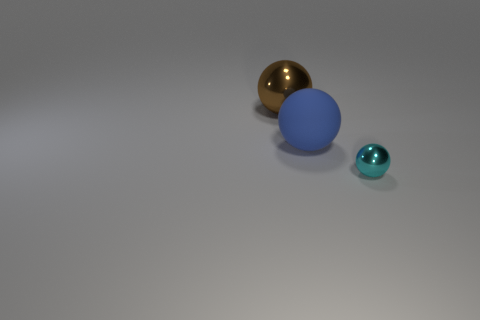Subtract all big spheres. How many spheres are left? 1 Add 3 large matte spheres. How many objects exist? 6 Subtract 0 green balls. How many objects are left? 3 Subtract all cyan shiny spheres. Subtract all metal things. How many objects are left? 0 Add 2 blue rubber things. How many blue rubber things are left? 3 Add 2 blue balls. How many blue balls exist? 3 